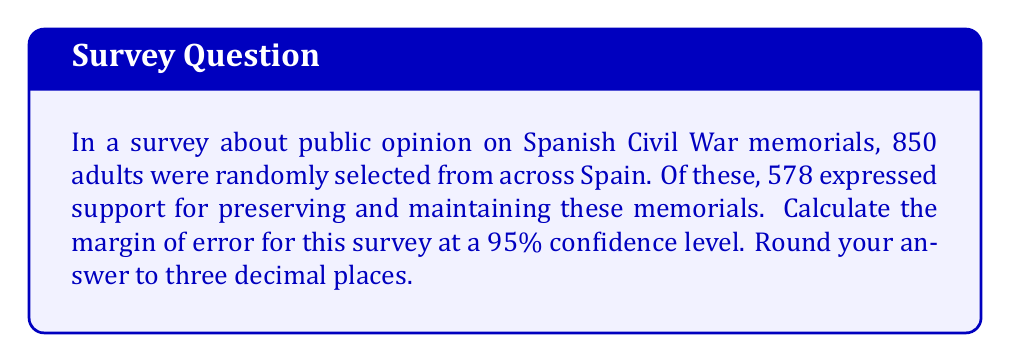Can you answer this question? Let's approach this step-by-step:

1) The margin of error formula for a proportion is:

   $$ME = z \sqrt{\frac{p(1-p)}{n}}$$

   where:
   - $z$ is the z-score for the desired confidence level
   - $p$ is the sample proportion
   - $n$ is the sample size

2) For a 95% confidence level, $z = 1.96$

3) Calculate the sample proportion $p$:
   $$p = \frac{578}{850} = 0.68$$

4) Now, let's plug these values into our formula:

   $$ME = 1.96 \sqrt{\frac{0.68(1-0.68)}{850}}$$

5) Simplify:
   $$ME = 1.96 \sqrt{\frac{0.68(0.32)}{850}}$$
   $$ME = 1.96 \sqrt{\frac{0.2176}{850}}$$
   $$ME = 1.96 \sqrt{0.000256}$$
   $$ME = 1.96 * 0.016$$
   $$ME = 0.03136$$

6) Rounding to three decimal places:
   $$ME = 0.031 = 3.1\%$$

This means we can be 95% confident that the true population proportion is within ±3.1% of our sample proportion.
Answer: 0.031 or 3.1% 